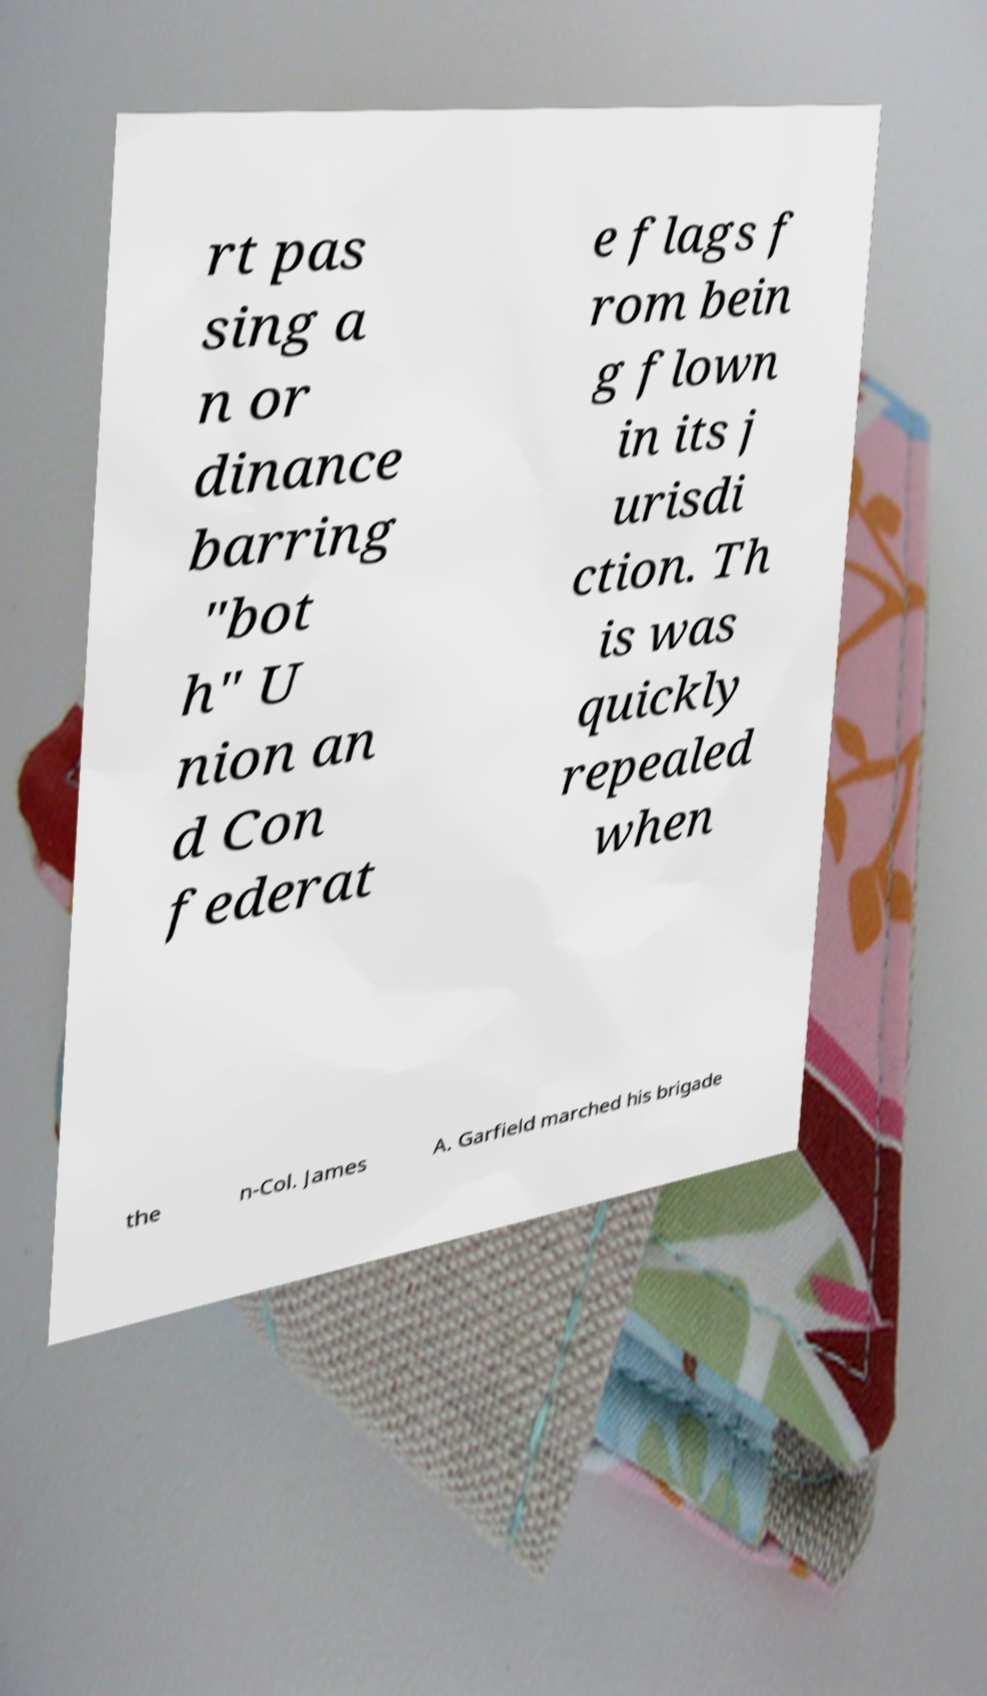Please read and relay the text visible in this image. What does it say? rt pas sing a n or dinance barring "bot h" U nion an d Con federat e flags f rom bein g flown in its j urisdi ction. Th is was quickly repealed when the n-Col. James A. Garfield marched his brigade 